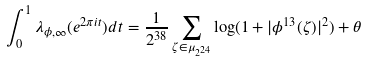<formula> <loc_0><loc_0><loc_500><loc_500>\int _ { 0 } ^ { 1 } \lambda _ { \phi , \infty } ( e ^ { 2 \pi i t } ) d t = \frac { 1 } { 2 ^ { 3 8 } } \sum _ { \zeta \in \mu _ { 2 ^ { 2 4 } } } \log ( 1 + | \phi ^ { 1 3 } ( \zeta ) | ^ { 2 } ) + \theta</formula> 